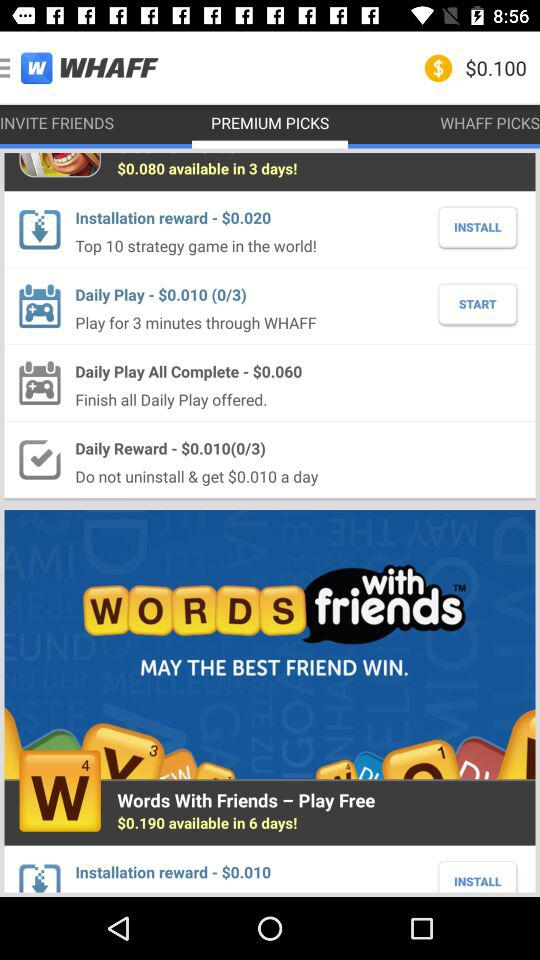What is the amount of the installation reward? The amounts are $0.020 and $0.010. 